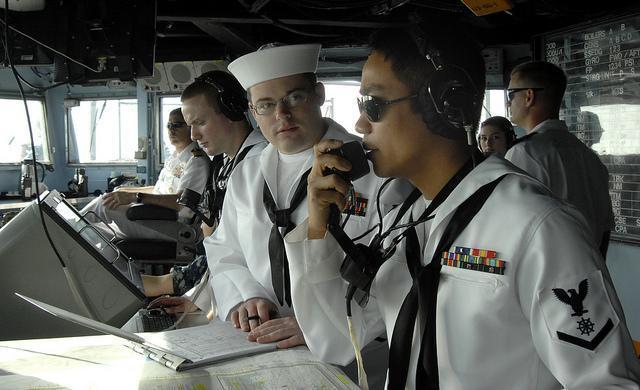How many sailors are in this image?
Give a very brief answer. 6. How many are wearing hats?
Give a very brief answer. 1. How many mice can be seen?
Give a very brief answer. 1. How many people can be seen?
Give a very brief answer. 5. How many ties are in the picture?
Give a very brief answer. 2. 